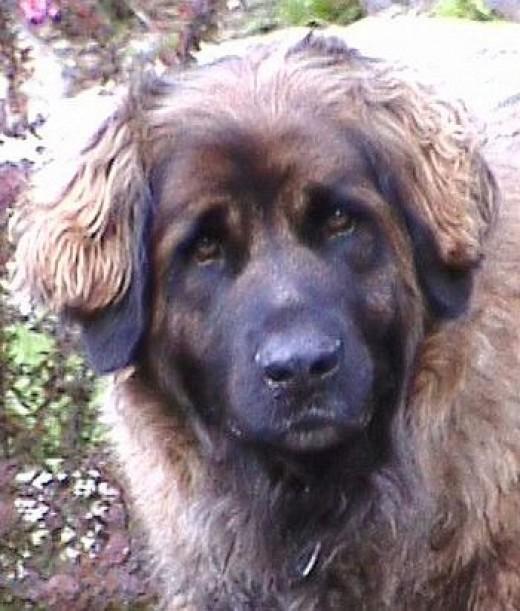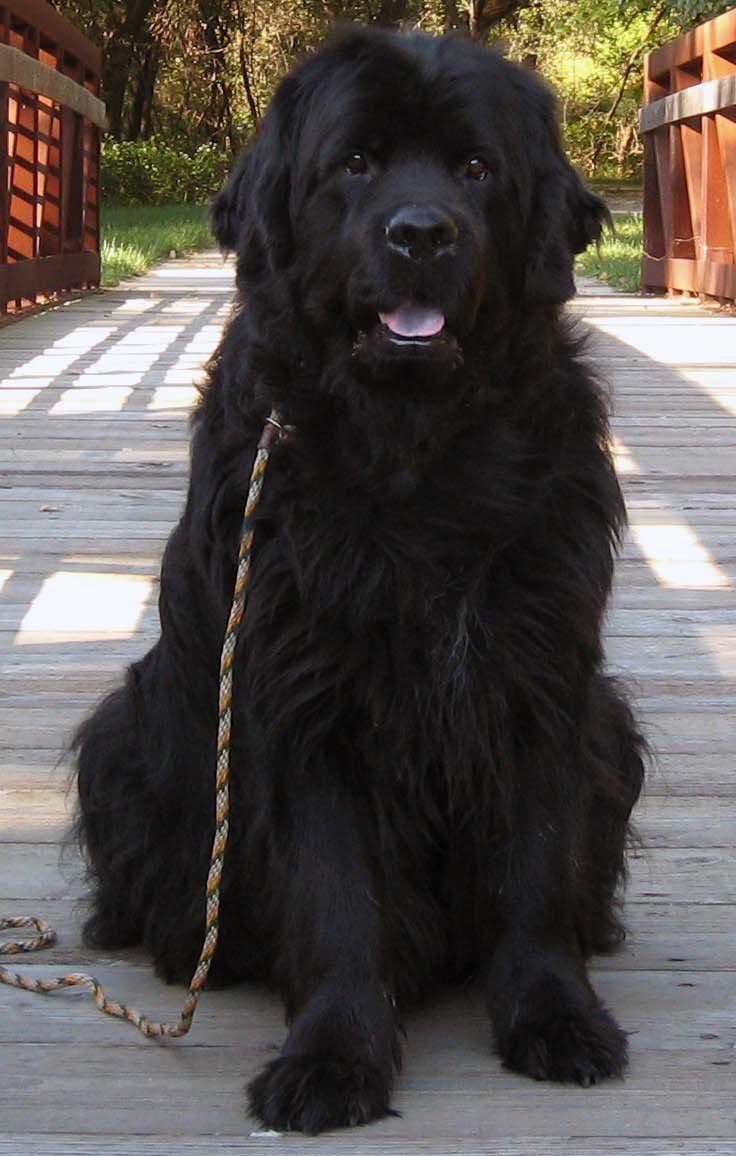The first image is the image on the left, the second image is the image on the right. For the images shown, is this caption "Christmas decorations can be seen in one of the pictures." true? Answer yes or no. No. The first image is the image on the left, the second image is the image on the right. Analyze the images presented: Is the assertion "Santa-themed red and white attire is included in one image with at least one dog." valid? Answer yes or no. No. 